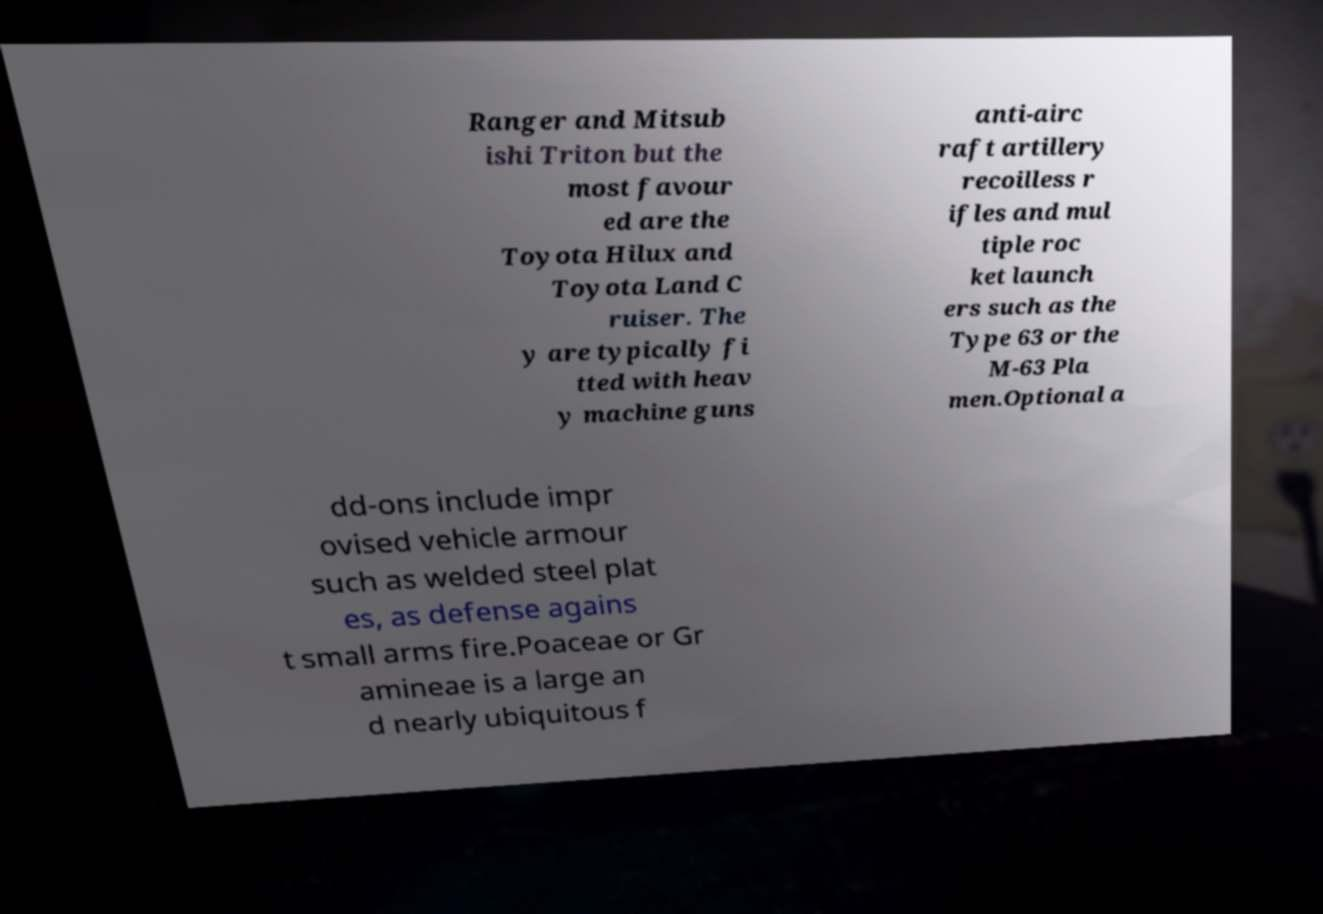What messages or text are displayed in this image? I need them in a readable, typed format. Ranger and Mitsub ishi Triton but the most favour ed are the Toyota Hilux and Toyota Land C ruiser. The y are typically fi tted with heav y machine guns anti-airc raft artillery recoilless r ifles and mul tiple roc ket launch ers such as the Type 63 or the M-63 Pla men.Optional a dd-ons include impr ovised vehicle armour such as welded steel plat es, as defense agains t small arms fire.Poaceae or Gr amineae is a large an d nearly ubiquitous f 